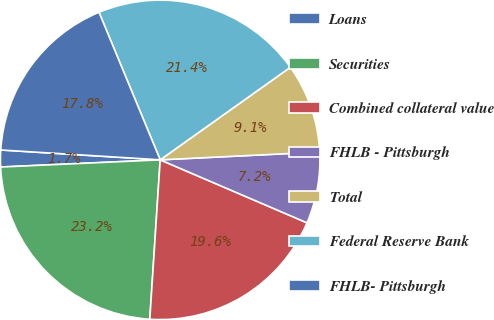Convert chart to OTSL. <chart><loc_0><loc_0><loc_500><loc_500><pie_chart><fcel>Loans<fcel>Securities<fcel>Combined collateral value<fcel>FHLB - Pittsburgh<fcel>Total<fcel>Federal Reserve Bank<fcel>FHLB- Pittsburgh<nl><fcel>1.7%<fcel>23.25%<fcel>19.59%<fcel>7.23%<fcel>9.06%<fcel>21.42%<fcel>17.76%<nl></chart> 